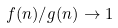Convert formula to latex. <formula><loc_0><loc_0><loc_500><loc_500>f ( n ) / g ( n ) \rightarrow 1</formula> 